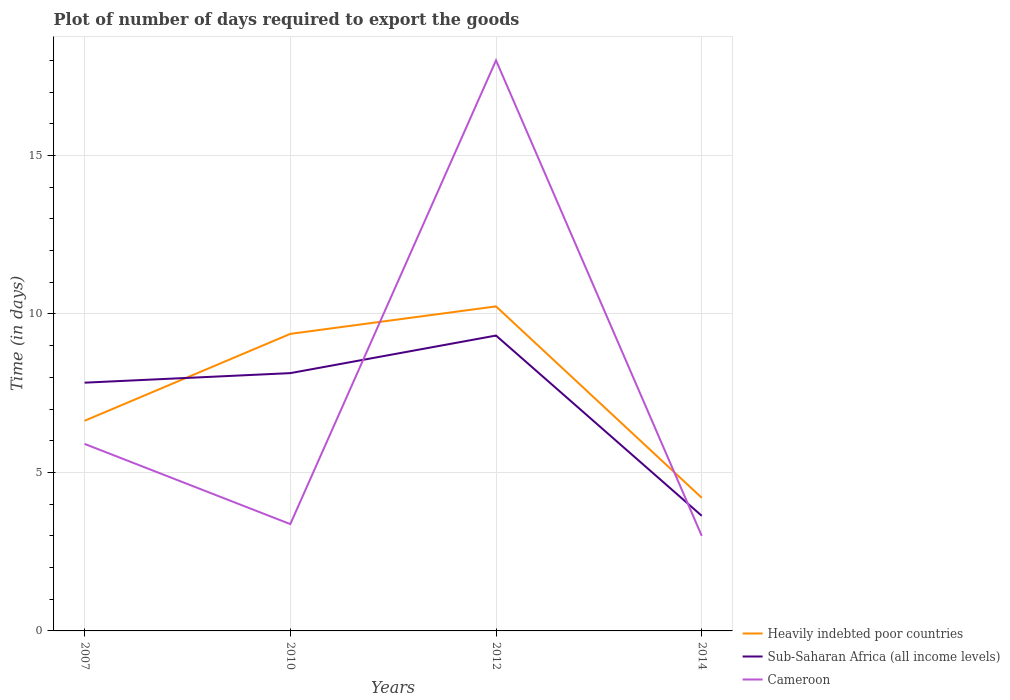How many different coloured lines are there?
Keep it short and to the point. 3. Is the number of lines equal to the number of legend labels?
Your answer should be compact. Yes. Across all years, what is the maximum time required to export goods in Sub-Saharan Africa (all income levels)?
Provide a succinct answer. 3.63. In which year was the time required to export goods in Sub-Saharan Africa (all income levels) maximum?
Keep it short and to the point. 2014. What is the total time required to export goods in Cameroon in the graph?
Offer a very short reply. 2.9. What is the difference between the highest and the lowest time required to export goods in Sub-Saharan Africa (all income levels)?
Give a very brief answer. 3. How many lines are there?
Keep it short and to the point. 3. How many years are there in the graph?
Your answer should be compact. 4. Does the graph contain any zero values?
Ensure brevity in your answer.  No. Does the graph contain grids?
Your answer should be compact. Yes. What is the title of the graph?
Offer a terse response. Plot of number of days required to export the goods. Does "Iceland" appear as one of the legend labels in the graph?
Ensure brevity in your answer.  No. What is the label or title of the X-axis?
Offer a terse response. Years. What is the label or title of the Y-axis?
Give a very brief answer. Time (in days). What is the Time (in days) in Heavily indebted poor countries in 2007?
Offer a very short reply. 6.63. What is the Time (in days) of Sub-Saharan Africa (all income levels) in 2007?
Your answer should be very brief. 7.83. What is the Time (in days) of Heavily indebted poor countries in 2010?
Your response must be concise. 9.37. What is the Time (in days) in Sub-Saharan Africa (all income levels) in 2010?
Offer a terse response. 8.13. What is the Time (in days) of Cameroon in 2010?
Your response must be concise. 3.37. What is the Time (in days) of Heavily indebted poor countries in 2012?
Provide a short and direct response. 10.24. What is the Time (in days) of Sub-Saharan Africa (all income levels) in 2012?
Your response must be concise. 9.32. What is the Time (in days) of Cameroon in 2012?
Make the answer very short. 18. What is the Time (in days) of Sub-Saharan Africa (all income levels) in 2014?
Offer a very short reply. 3.63. What is the Time (in days) of Cameroon in 2014?
Ensure brevity in your answer.  3. Across all years, what is the maximum Time (in days) in Heavily indebted poor countries?
Your response must be concise. 10.24. Across all years, what is the maximum Time (in days) of Sub-Saharan Africa (all income levels)?
Your answer should be very brief. 9.32. Across all years, what is the minimum Time (in days) in Heavily indebted poor countries?
Provide a short and direct response. 4.2. Across all years, what is the minimum Time (in days) of Sub-Saharan Africa (all income levels)?
Provide a short and direct response. 3.63. What is the total Time (in days) of Heavily indebted poor countries in the graph?
Your answer should be very brief. 30.44. What is the total Time (in days) in Sub-Saharan Africa (all income levels) in the graph?
Make the answer very short. 28.91. What is the total Time (in days) of Cameroon in the graph?
Your answer should be compact. 30.27. What is the difference between the Time (in days) of Heavily indebted poor countries in 2007 and that in 2010?
Your answer should be very brief. -2.74. What is the difference between the Time (in days) of Sub-Saharan Africa (all income levels) in 2007 and that in 2010?
Offer a very short reply. -0.3. What is the difference between the Time (in days) of Cameroon in 2007 and that in 2010?
Make the answer very short. 2.53. What is the difference between the Time (in days) in Heavily indebted poor countries in 2007 and that in 2012?
Make the answer very short. -3.61. What is the difference between the Time (in days) of Sub-Saharan Africa (all income levels) in 2007 and that in 2012?
Give a very brief answer. -1.49. What is the difference between the Time (in days) of Cameroon in 2007 and that in 2012?
Provide a succinct answer. -12.1. What is the difference between the Time (in days) of Heavily indebted poor countries in 2007 and that in 2014?
Your response must be concise. 2.43. What is the difference between the Time (in days) of Cameroon in 2007 and that in 2014?
Make the answer very short. 2.9. What is the difference between the Time (in days) in Heavily indebted poor countries in 2010 and that in 2012?
Your response must be concise. -0.87. What is the difference between the Time (in days) of Sub-Saharan Africa (all income levels) in 2010 and that in 2012?
Give a very brief answer. -1.19. What is the difference between the Time (in days) in Cameroon in 2010 and that in 2012?
Make the answer very short. -14.63. What is the difference between the Time (in days) of Heavily indebted poor countries in 2010 and that in 2014?
Provide a succinct answer. 5.17. What is the difference between the Time (in days) in Sub-Saharan Africa (all income levels) in 2010 and that in 2014?
Make the answer very short. 4.5. What is the difference between the Time (in days) in Cameroon in 2010 and that in 2014?
Offer a very short reply. 0.37. What is the difference between the Time (in days) in Heavily indebted poor countries in 2012 and that in 2014?
Offer a very short reply. 6.04. What is the difference between the Time (in days) in Sub-Saharan Africa (all income levels) in 2012 and that in 2014?
Keep it short and to the point. 5.69. What is the difference between the Time (in days) of Cameroon in 2012 and that in 2014?
Keep it short and to the point. 15. What is the difference between the Time (in days) in Heavily indebted poor countries in 2007 and the Time (in days) in Sub-Saharan Africa (all income levels) in 2010?
Your answer should be compact. -1.5. What is the difference between the Time (in days) of Heavily indebted poor countries in 2007 and the Time (in days) of Cameroon in 2010?
Keep it short and to the point. 3.26. What is the difference between the Time (in days) in Sub-Saharan Africa (all income levels) in 2007 and the Time (in days) in Cameroon in 2010?
Offer a terse response. 4.46. What is the difference between the Time (in days) in Heavily indebted poor countries in 2007 and the Time (in days) in Sub-Saharan Africa (all income levels) in 2012?
Your response must be concise. -2.69. What is the difference between the Time (in days) of Heavily indebted poor countries in 2007 and the Time (in days) of Cameroon in 2012?
Make the answer very short. -11.37. What is the difference between the Time (in days) of Sub-Saharan Africa (all income levels) in 2007 and the Time (in days) of Cameroon in 2012?
Provide a succinct answer. -10.17. What is the difference between the Time (in days) in Heavily indebted poor countries in 2007 and the Time (in days) in Sub-Saharan Africa (all income levels) in 2014?
Provide a short and direct response. 3. What is the difference between the Time (in days) in Heavily indebted poor countries in 2007 and the Time (in days) in Cameroon in 2014?
Make the answer very short. 3.63. What is the difference between the Time (in days) in Sub-Saharan Africa (all income levels) in 2007 and the Time (in days) in Cameroon in 2014?
Keep it short and to the point. 4.83. What is the difference between the Time (in days) in Heavily indebted poor countries in 2010 and the Time (in days) in Sub-Saharan Africa (all income levels) in 2012?
Ensure brevity in your answer.  0.05. What is the difference between the Time (in days) in Heavily indebted poor countries in 2010 and the Time (in days) in Cameroon in 2012?
Provide a short and direct response. -8.63. What is the difference between the Time (in days) in Sub-Saharan Africa (all income levels) in 2010 and the Time (in days) in Cameroon in 2012?
Offer a very short reply. -9.87. What is the difference between the Time (in days) in Heavily indebted poor countries in 2010 and the Time (in days) in Sub-Saharan Africa (all income levels) in 2014?
Your response must be concise. 5.74. What is the difference between the Time (in days) of Heavily indebted poor countries in 2010 and the Time (in days) of Cameroon in 2014?
Your answer should be very brief. 6.37. What is the difference between the Time (in days) in Sub-Saharan Africa (all income levels) in 2010 and the Time (in days) in Cameroon in 2014?
Make the answer very short. 5.13. What is the difference between the Time (in days) of Heavily indebted poor countries in 2012 and the Time (in days) of Sub-Saharan Africa (all income levels) in 2014?
Your response must be concise. 6.61. What is the difference between the Time (in days) of Heavily indebted poor countries in 2012 and the Time (in days) of Cameroon in 2014?
Provide a succinct answer. 7.24. What is the difference between the Time (in days) of Sub-Saharan Africa (all income levels) in 2012 and the Time (in days) of Cameroon in 2014?
Give a very brief answer. 6.32. What is the average Time (in days) of Heavily indebted poor countries per year?
Your answer should be very brief. 7.61. What is the average Time (in days) of Sub-Saharan Africa (all income levels) per year?
Give a very brief answer. 7.23. What is the average Time (in days) in Cameroon per year?
Give a very brief answer. 7.57. In the year 2007, what is the difference between the Time (in days) of Heavily indebted poor countries and Time (in days) of Sub-Saharan Africa (all income levels)?
Provide a short and direct response. -1.2. In the year 2007, what is the difference between the Time (in days) of Heavily indebted poor countries and Time (in days) of Cameroon?
Give a very brief answer. 0.73. In the year 2007, what is the difference between the Time (in days) in Sub-Saharan Africa (all income levels) and Time (in days) in Cameroon?
Your answer should be compact. 1.93. In the year 2010, what is the difference between the Time (in days) in Heavily indebted poor countries and Time (in days) in Sub-Saharan Africa (all income levels)?
Offer a terse response. 1.24. In the year 2010, what is the difference between the Time (in days) of Heavily indebted poor countries and Time (in days) of Cameroon?
Make the answer very short. 6. In the year 2010, what is the difference between the Time (in days) in Sub-Saharan Africa (all income levels) and Time (in days) in Cameroon?
Offer a very short reply. 4.76. In the year 2012, what is the difference between the Time (in days) of Heavily indebted poor countries and Time (in days) of Sub-Saharan Africa (all income levels)?
Provide a short and direct response. 0.92. In the year 2012, what is the difference between the Time (in days) in Heavily indebted poor countries and Time (in days) in Cameroon?
Your response must be concise. -7.76. In the year 2012, what is the difference between the Time (in days) of Sub-Saharan Africa (all income levels) and Time (in days) of Cameroon?
Offer a terse response. -8.68. In the year 2014, what is the difference between the Time (in days) of Heavily indebted poor countries and Time (in days) of Sub-Saharan Africa (all income levels)?
Offer a terse response. 0.57. In the year 2014, what is the difference between the Time (in days) in Heavily indebted poor countries and Time (in days) in Cameroon?
Your answer should be compact. 1.2. In the year 2014, what is the difference between the Time (in days) of Sub-Saharan Africa (all income levels) and Time (in days) of Cameroon?
Offer a very short reply. 0.63. What is the ratio of the Time (in days) of Heavily indebted poor countries in 2007 to that in 2010?
Your answer should be compact. 0.71. What is the ratio of the Time (in days) of Cameroon in 2007 to that in 2010?
Ensure brevity in your answer.  1.75. What is the ratio of the Time (in days) in Heavily indebted poor countries in 2007 to that in 2012?
Give a very brief answer. 0.65. What is the ratio of the Time (in days) in Sub-Saharan Africa (all income levels) in 2007 to that in 2012?
Ensure brevity in your answer.  0.84. What is the ratio of the Time (in days) of Cameroon in 2007 to that in 2012?
Your response must be concise. 0.33. What is the ratio of the Time (in days) in Heavily indebted poor countries in 2007 to that in 2014?
Provide a succinct answer. 1.58. What is the ratio of the Time (in days) in Sub-Saharan Africa (all income levels) in 2007 to that in 2014?
Your response must be concise. 2.16. What is the ratio of the Time (in days) of Cameroon in 2007 to that in 2014?
Offer a very short reply. 1.97. What is the ratio of the Time (in days) of Heavily indebted poor countries in 2010 to that in 2012?
Keep it short and to the point. 0.92. What is the ratio of the Time (in days) of Sub-Saharan Africa (all income levels) in 2010 to that in 2012?
Your answer should be very brief. 0.87. What is the ratio of the Time (in days) of Cameroon in 2010 to that in 2012?
Offer a very short reply. 0.19. What is the ratio of the Time (in days) in Heavily indebted poor countries in 2010 to that in 2014?
Give a very brief answer. 2.23. What is the ratio of the Time (in days) of Sub-Saharan Africa (all income levels) in 2010 to that in 2014?
Keep it short and to the point. 2.24. What is the ratio of the Time (in days) of Cameroon in 2010 to that in 2014?
Your answer should be compact. 1.12. What is the ratio of the Time (in days) in Heavily indebted poor countries in 2012 to that in 2014?
Your answer should be compact. 2.44. What is the ratio of the Time (in days) of Sub-Saharan Africa (all income levels) in 2012 to that in 2014?
Provide a succinct answer. 2.57. What is the difference between the highest and the second highest Time (in days) in Heavily indebted poor countries?
Make the answer very short. 0.87. What is the difference between the highest and the second highest Time (in days) in Sub-Saharan Africa (all income levels)?
Your answer should be very brief. 1.19. What is the difference between the highest and the second highest Time (in days) in Cameroon?
Your answer should be compact. 12.1. What is the difference between the highest and the lowest Time (in days) of Heavily indebted poor countries?
Provide a succinct answer. 6.04. What is the difference between the highest and the lowest Time (in days) in Sub-Saharan Africa (all income levels)?
Ensure brevity in your answer.  5.69. What is the difference between the highest and the lowest Time (in days) of Cameroon?
Ensure brevity in your answer.  15. 